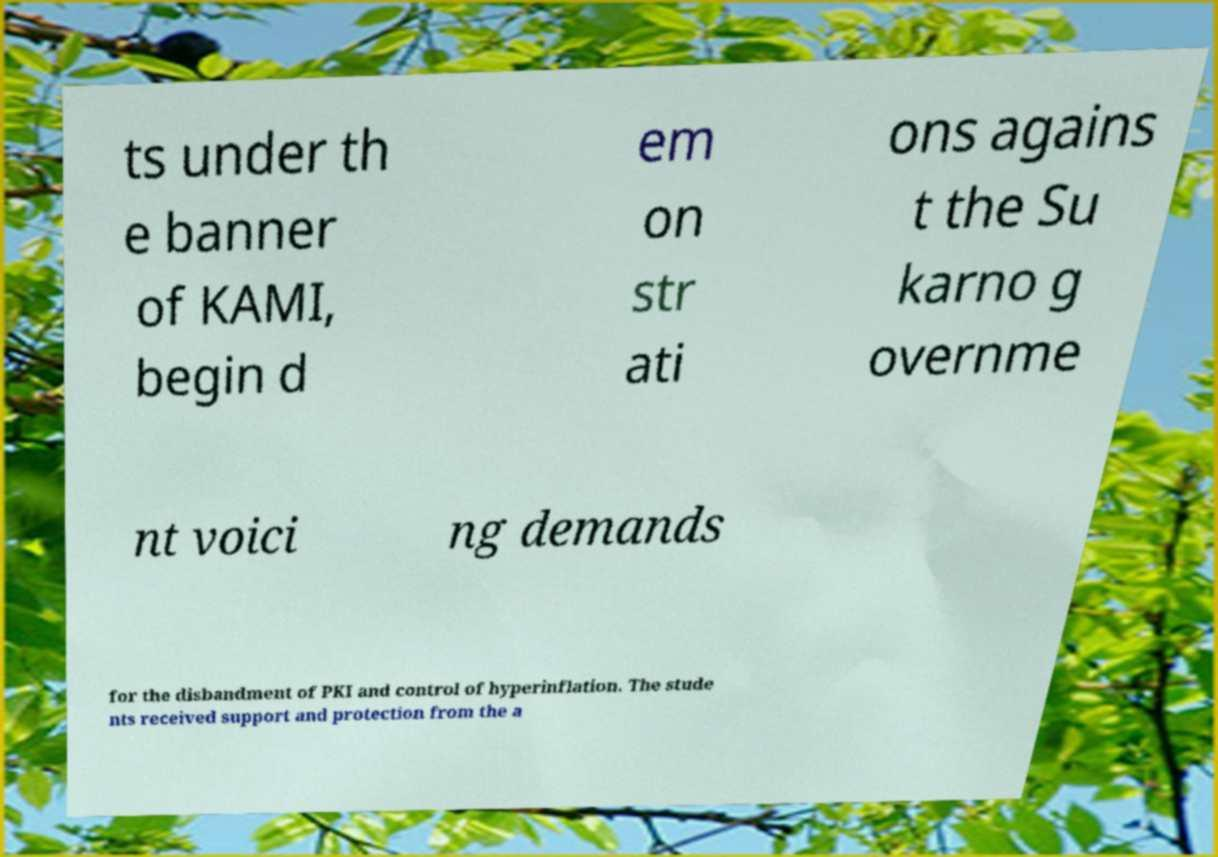Can you read and provide the text displayed in the image?This photo seems to have some interesting text. Can you extract and type it out for me? ts under th e banner of KAMI, begin d em on str ati ons agains t the Su karno g overnme nt voici ng demands for the disbandment of PKI and control of hyperinflation. The stude nts received support and protection from the a 